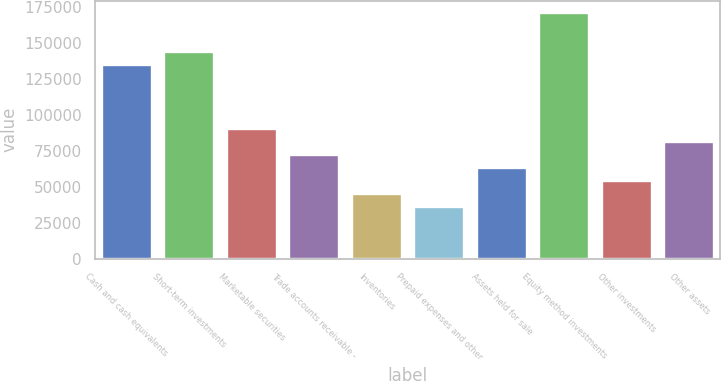<chart> <loc_0><loc_0><loc_500><loc_500><bar_chart><fcel>Cash and cash equivalents<fcel>Short-term investments<fcel>Marketable securities<fcel>Trade accounts receivable -<fcel>Inventories<fcel>Prepaid expenses and other<fcel>Assets held for sale<fcel>Equity method investments<fcel>Other investments<fcel>Other assets<nl><fcel>134974<fcel>143950<fcel>90093<fcel>72140.6<fcel>45212<fcel>36235.8<fcel>63164.4<fcel>170879<fcel>54188.2<fcel>81116.8<nl></chart> 